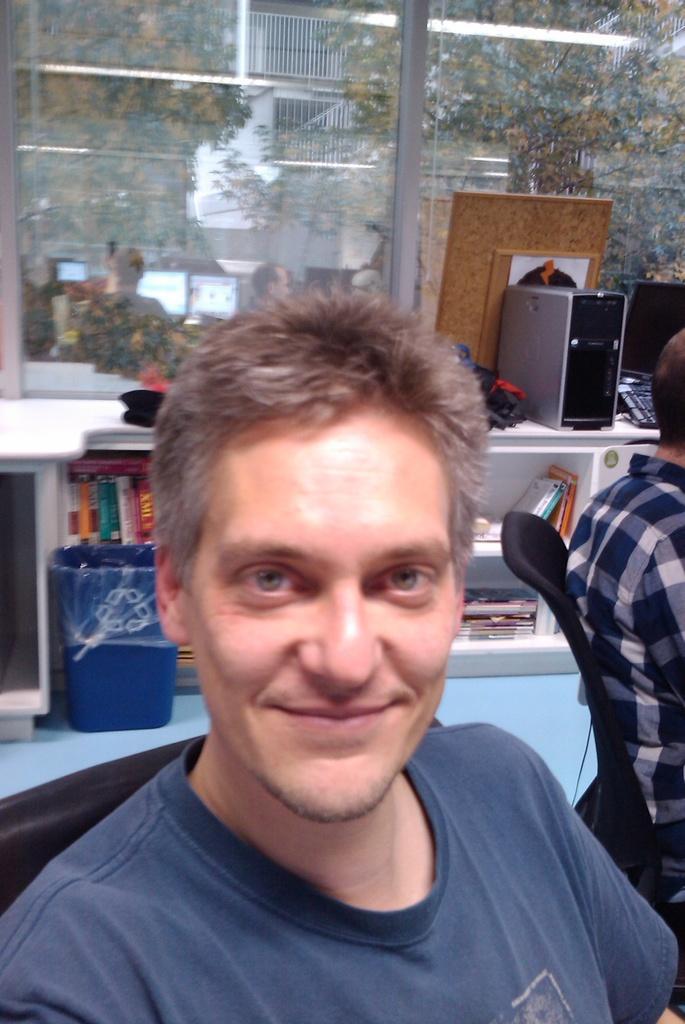In one or two sentences, can you explain what this image depicts? This is the picture of a place where we have a person and behind there are some things on the desk and the other person to the side. 